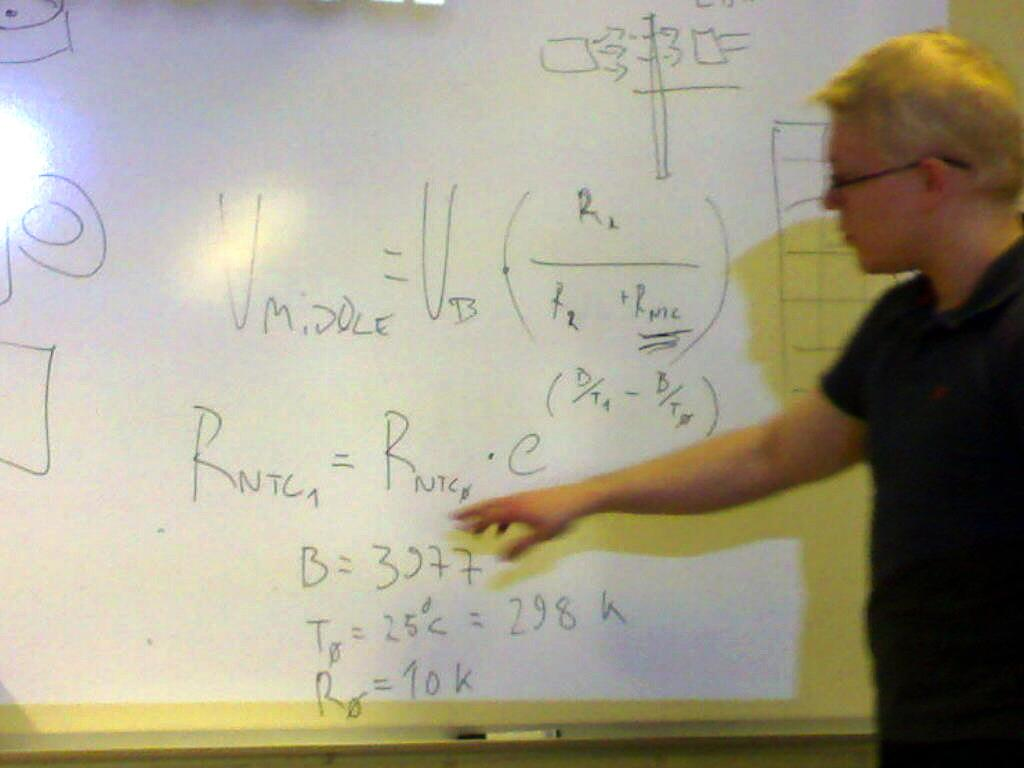<image>
Render a clear and concise summary of the photo. Someone is working on an equation about Vmiddle and Vb. 